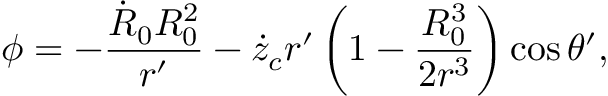<formula> <loc_0><loc_0><loc_500><loc_500>\phi = - \frac { \dot { R } _ { 0 } R _ { 0 } ^ { 2 } } { r ^ { \prime } } - \dot { z } _ { c } r ^ { \prime } \left ( 1 - \frac { R _ { 0 } ^ { 3 } } { 2 r ^ { 3 } } \right ) \cos \theta ^ { \prime } ,</formula> 